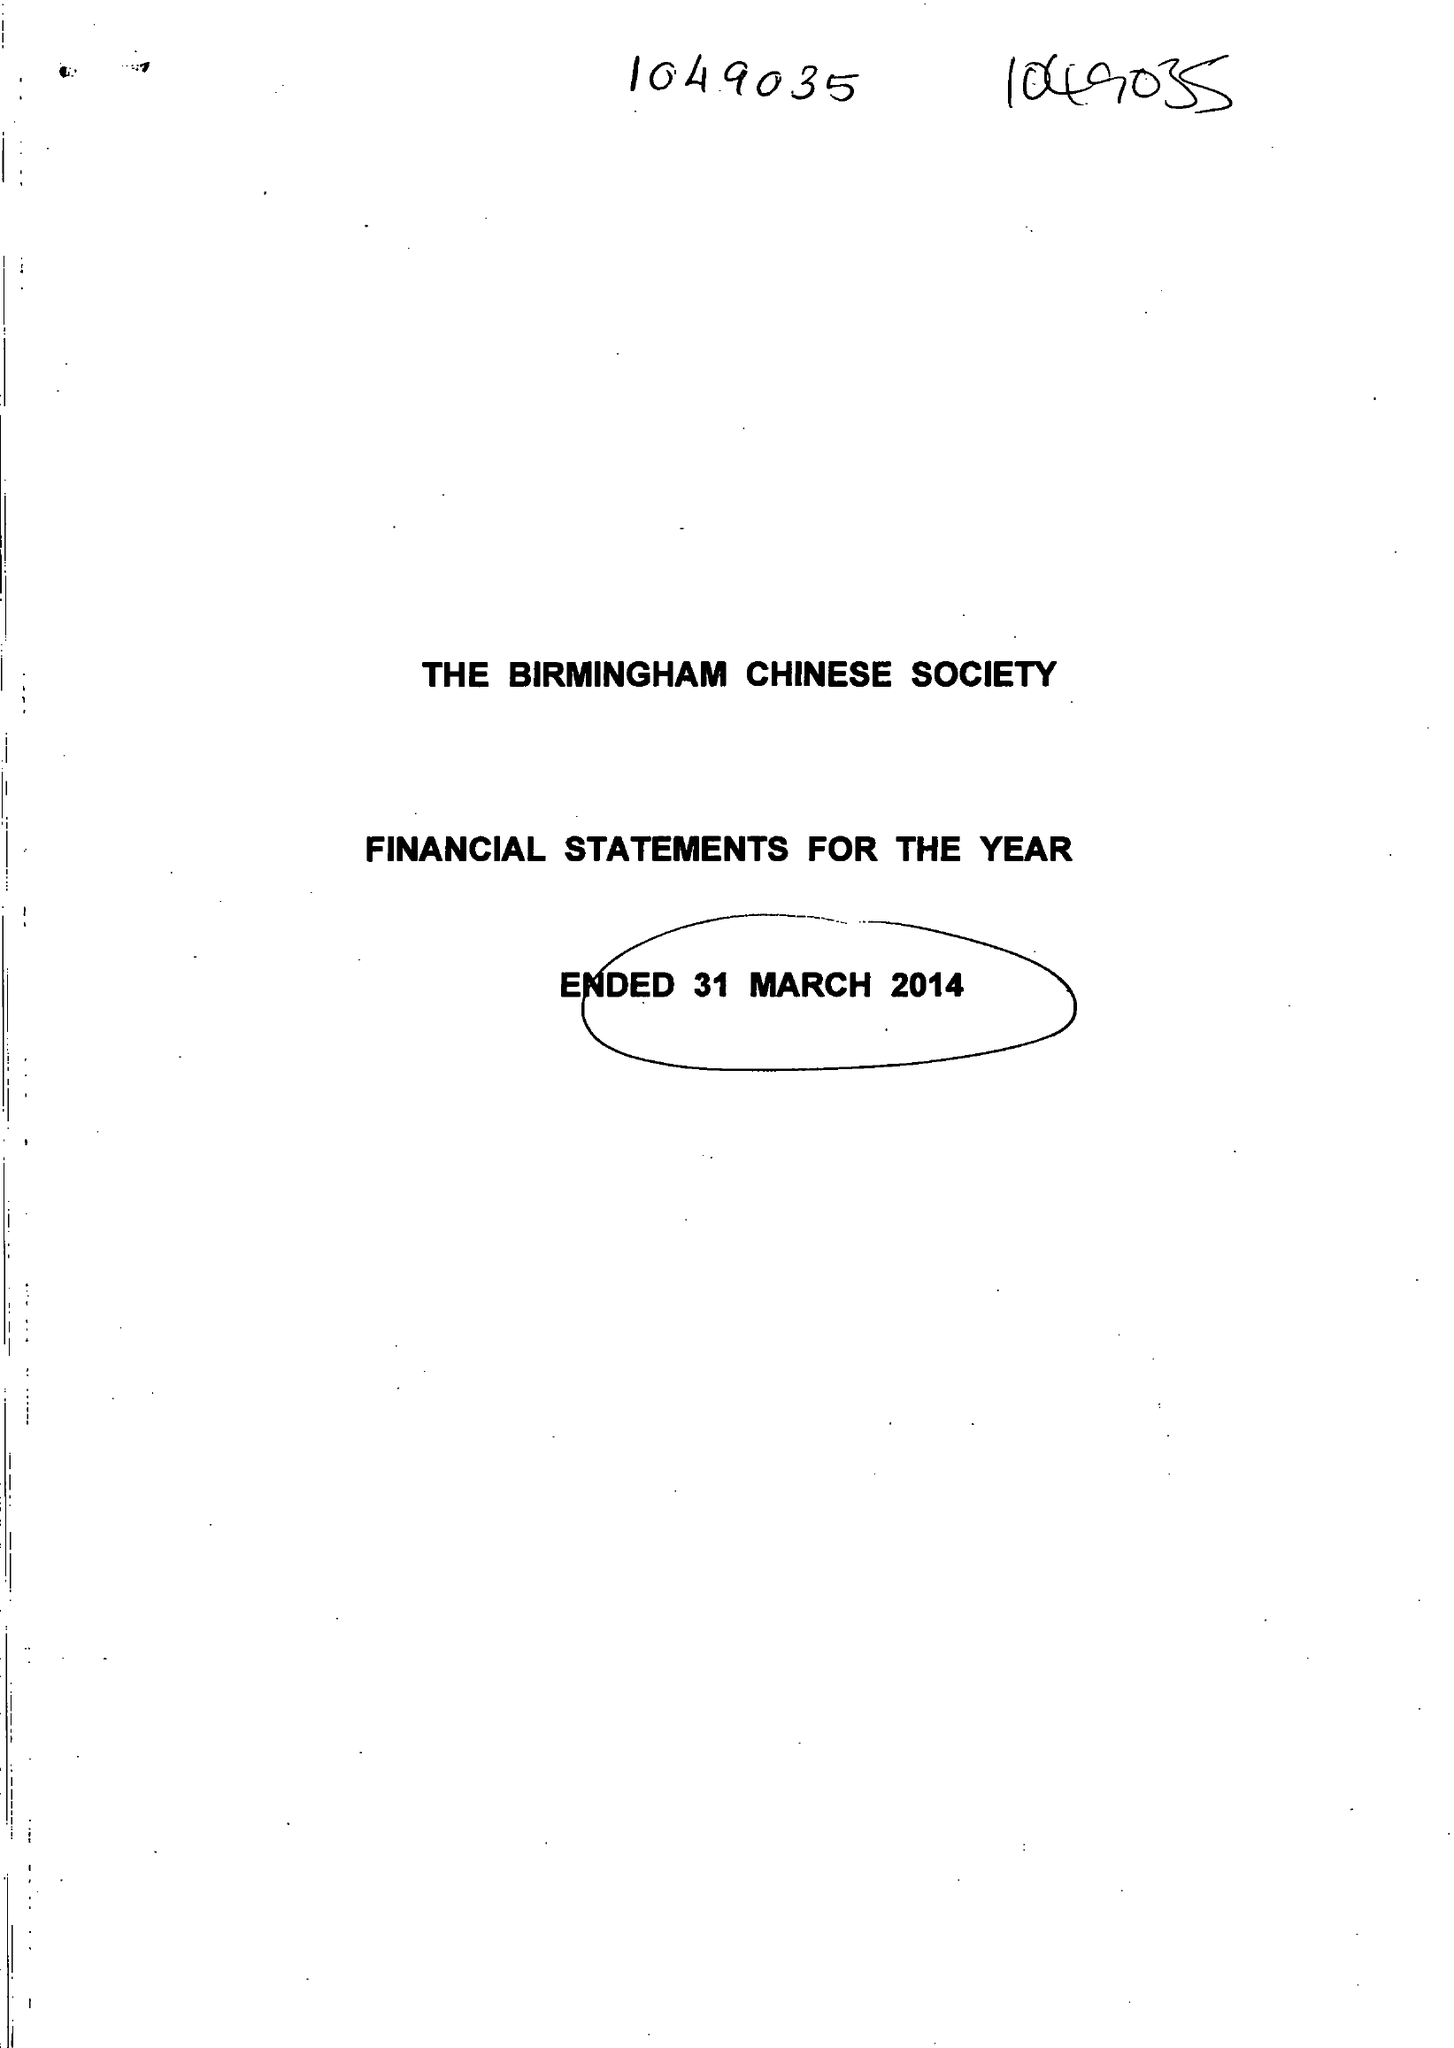What is the value for the charity_number?
Answer the question using a single word or phrase. 1049035 